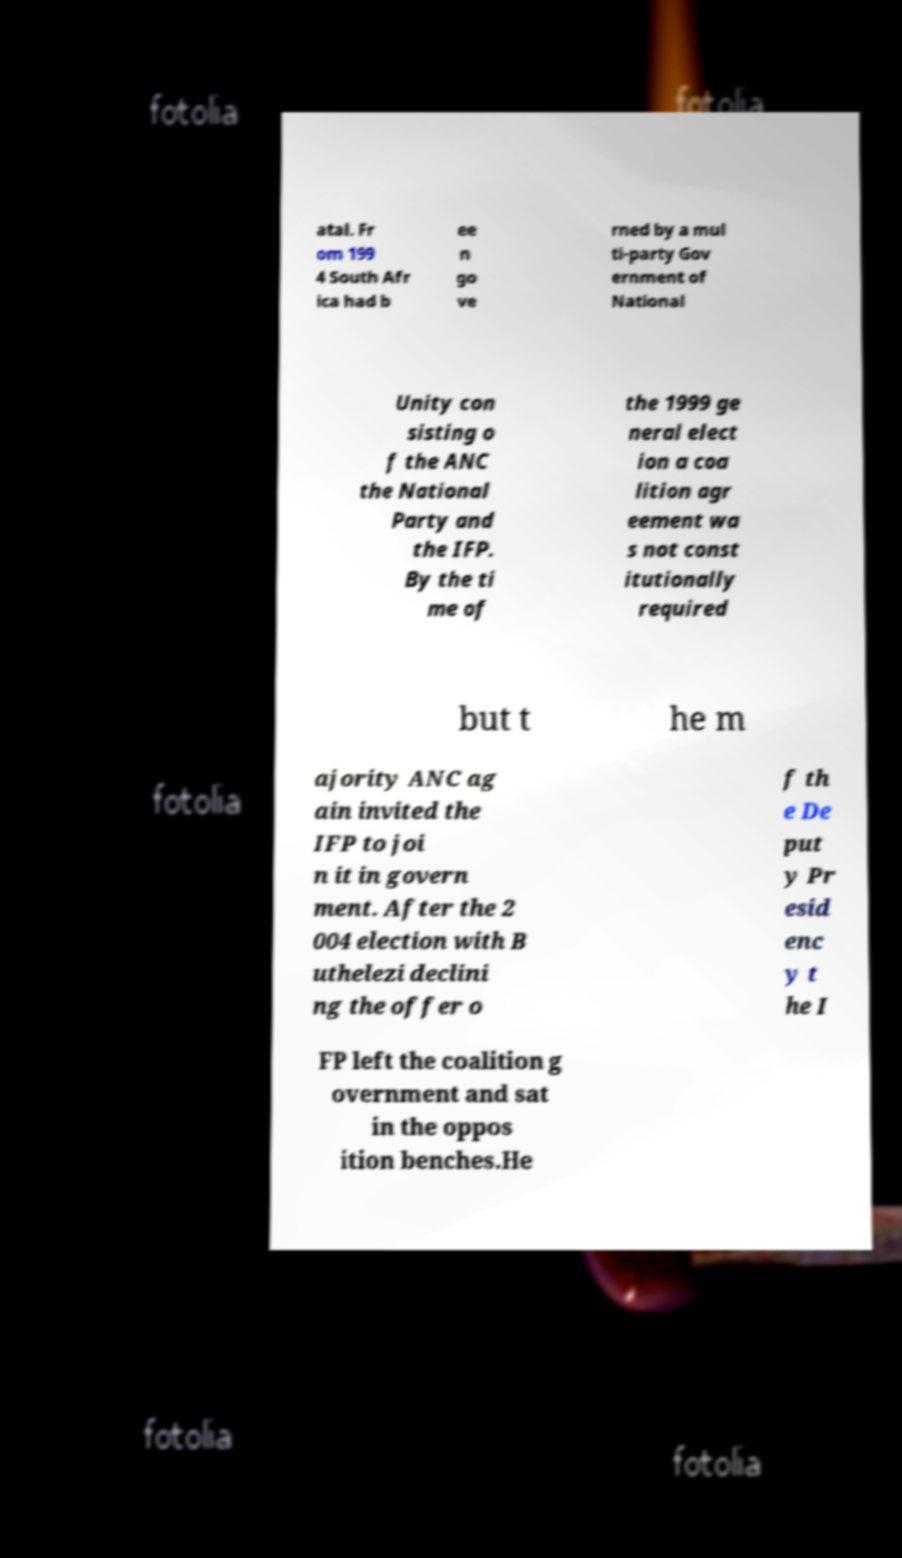Could you assist in decoding the text presented in this image and type it out clearly? atal. Fr om 199 4 South Afr ica had b ee n go ve rned by a mul ti-party Gov ernment of National Unity con sisting o f the ANC the National Party and the IFP. By the ti me of the 1999 ge neral elect ion a coa lition agr eement wa s not const itutionally required but t he m ajority ANC ag ain invited the IFP to joi n it in govern ment. After the 2 004 election with B uthelezi declini ng the offer o f th e De put y Pr esid enc y t he I FP left the coalition g overnment and sat in the oppos ition benches.He 